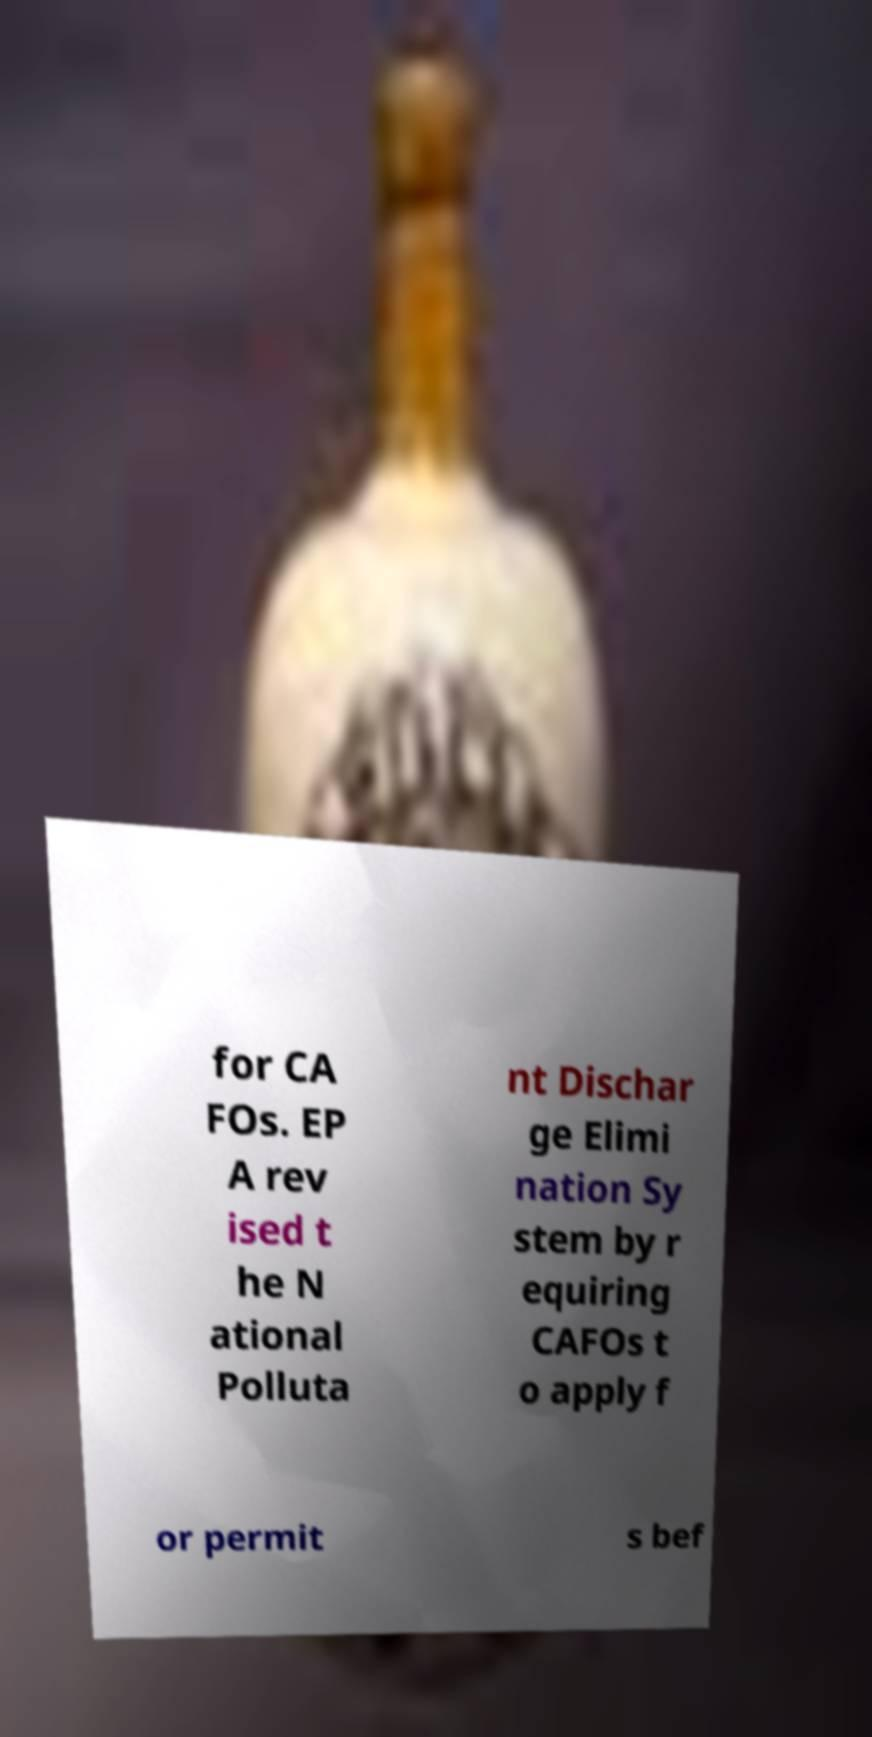What messages or text are displayed in this image? I need them in a readable, typed format. for CA FOs. EP A rev ised t he N ational Polluta nt Dischar ge Elimi nation Sy stem by r equiring CAFOs t o apply f or permit s bef 